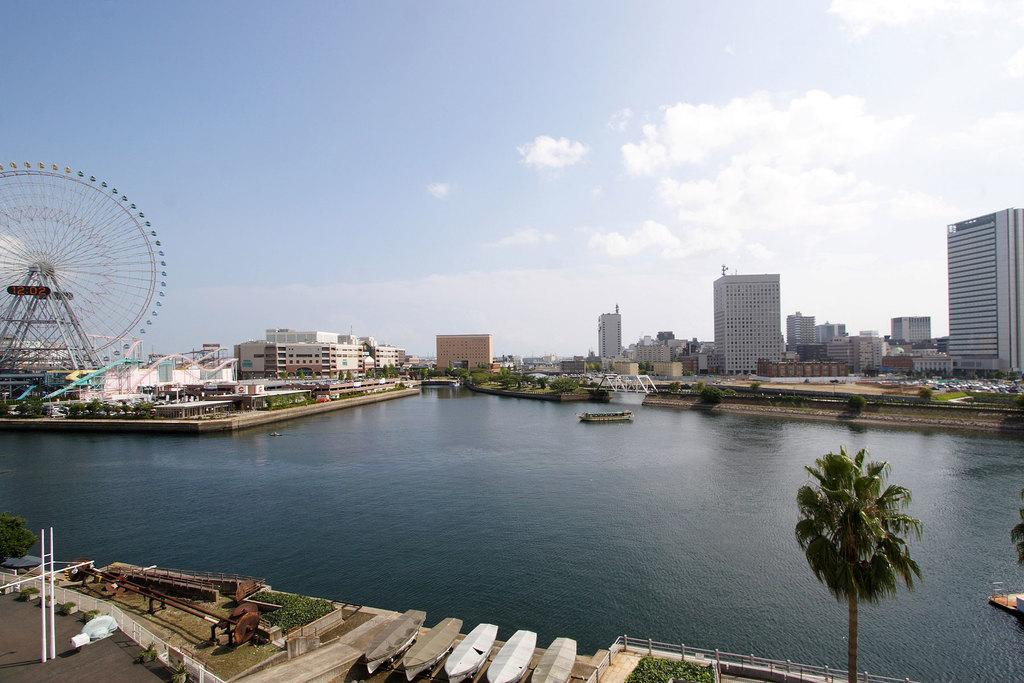What can be seen in the sky in the image? The sky with clouds is visible in the image. What type of structures are present in the image? There are buildings, skyscrapers, and a giant wheel in the image. What natural elements can be seen in the image? Trees and bushes are visible in the image. What type of entertainment is present in the image? Fun rides are visible in the image. What mode of transportation can be seen in the image? Ships on the water are present in the image. What additional features can be seen in the image? Railings, a sculpture, and barrier poles are present in the image. What language is spoken by the people in the image? There are no people visible in the image, so it is impossible to determine the language spoken. What type of pail is used to collect water in the image? There is no pail present in the image. 